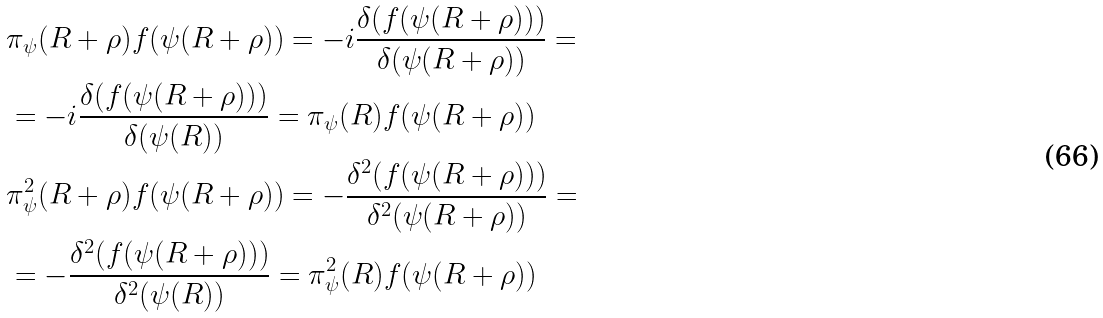Convert formula to latex. <formula><loc_0><loc_0><loc_500><loc_500>& \pi _ { \psi } ( R + \rho ) f ( \psi ( R + \rho ) ) = - i \frac { \delta ( f ( \psi ( R + \rho ) ) ) } { \delta ( \psi ( R + \rho ) ) } = \\ & = - i \frac { \delta ( f ( \psi ( R + \rho ) ) ) } { \delta ( \psi ( R ) ) } = \pi _ { \psi } ( R ) f ( \psi ( R + \rho ) ) \\ & \pi ^ { 2 } _ { \psi } ( R + \rho ) f ( \psi ( R + \rho ) ) = - \frac { \delta ^ { 2 } ( f ( \psi ( R + \rho ) ) ) } { \delta ^ { 2 } ( \psi ( R + \rho ) ) } = \\ & = - \frac { \delta ^ { 2 } ( f ( \psi ( R + \rho ) ) ) } { \delta ^ { 2 } ( \psi ( R ) ) } = \pi ^ { 2 } _ { \psi } ( R ) f ( \psi ( R + \rho ) )</formula> 